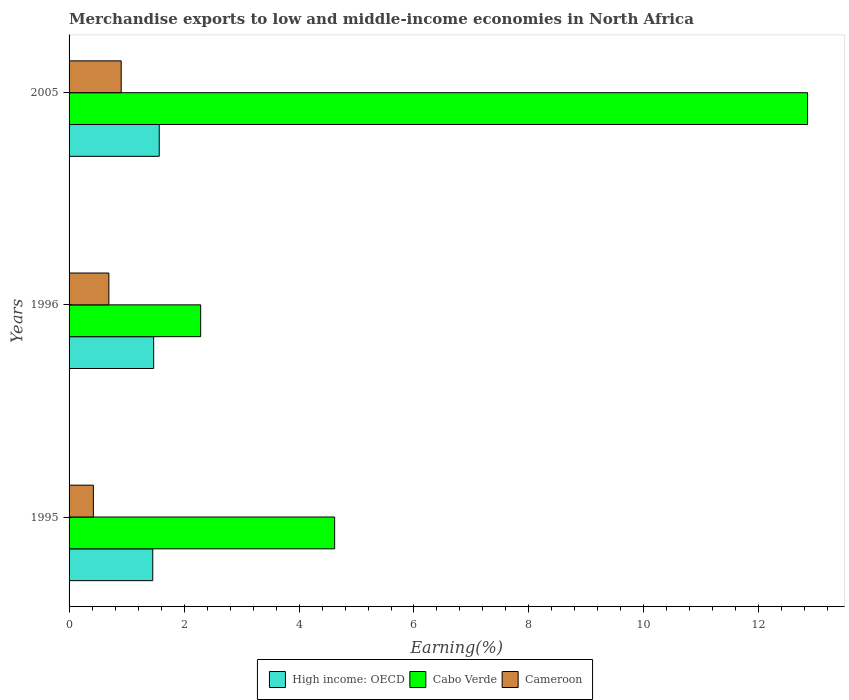How many groups of bars are there?
Provide a short and direct response. 3. Are the number of bars on each tick of the Y-axis equal?
Give a very brief answer. Yes. What is the percentage of amount earned from merchandise exports in Cabo Verde in 1995?
Provide a succinct answer. 4.62. Across all years, what is the maximum percentage of amount earned from merchandise exports in Cameroon?
Keep it short and to the point. 0.91. Across all years, what is the minimum percentage of amount earned from merchandise exports in High income: OECD?
Your answer should be very brief. 1.46. In which year was the percentage of amount earned from merchandise exports in Cameroon minimum?
Offer a very short reply. 1995. What is the total percentage of amount earned from merchandise exports in Cabo Verde in the graph?
Your answer should be very brief. 19.76. What is the difference between the percentage of amount earned from merchandise exports in Cameroon in 1995 and that in 2005?
Your answer should be very brief. -0.48. What is the difference between the percentage of amount earned from merchandise exports in Cabo Verde in 1996 and the percentage of amount earned from merchandise exports in Cameroon in 1995?
Provide a succinct answer. 1.87. What is the average percentage of amount earned from merchandise exports in Cabo Verde per year?
Provide a succinct answer. 6.59. In the year 1995, what is the difference between the percentage of amount earned from merchandise exports in Cameroon and percentage of amount earned from merchandise exports in High income: OECD?
Give a very brief answer. -1.03. In how many years, is the percentage of amount earned from merchandise exports in Cameroon greater than 8.4 %?
Keep it short and to the point. 0. What is the ratio of the percentage of amount earned from merchandise exports in Cameroon in 1995 to that in 1996?
Your answer should be very brief. 0.61. Is the percentage of amount earned from merchandise exports in Cabo Verde in 1996 less than that in 2005?
Offer a very short reply. Yes. What is the difference between the highest and the second highest percentage of amount earned from merchandise exports in High income: OECD?
Make the answer very short. 0.1. What is the difference between the highest and the lowest percentage of amount earned from merchandise exports in Cameroon?
Your answer should be very brief. 0.48. In how many years, is the percentage of amount earned from merchandise exports in Cameroon greater than the average percentage of amount earned from merchandise exports in Cameroon taken over all years?
Make the answer very short. 2. What does the 2nd bar from the top in 1995 represents?
Offer a terse response. Cabo Verde. What does the 3rd bar from the bottom in 1996 represents?
Make the answer very short. Cameroon. Is it the case that in every year, the sum of the percentage of amount earned from merchandise exports in High income: OECD and percentage of amount earned from merchandise exports in Cameroon is greater than the percentage of amount earned from merchandise exports in Cabo Verde?
Your answer should be very brief. No. How many bars are there?
Your answer should be compact. 9. Are the values on the major ticks of X-axis written in scientific E-notation?
Ensure brevity in your answer.  No. Does the graph contain any zero values?
Your answer should be compact. No. Does the graph contain grids?
Make the answer very short. No. Where does the legend appear in the graph?
Give a very brief answer. Bottom center. How many legend labels are there?
Make the answer very short. 3. How are the legend labels stacked?
Your answer should be compact. Horizontal. What is the title of the graph?
Your response must be concise. Merchandise exports to low and middle-income economies in North Africa. Does "New Caledonia" appear as one of the legend labels in the graph?
Your answer should be very brief. No. What is the label or title of the X-axis?
Your answer should be compact. Earning(%). What is the label or title of the Y-axis?
Your response must be concise. Years. What is the Earning(%) in High income: OECD in 1995?
Your response must be concise. 1.46. What is the Earning(%) in Cabo Verde in 1995?
Ensure brevity in your answer.  4.62. What is the Earning(%) in Cameroon in 1995?
Provide a succinct answer. 0.42. What is the Earning(%) of High income: OECD in 1996?
Your answer should be compact. 1.47. What is the Earning(%) in Cabo Verde in 1996?
Your answer should be compact. 2.29. What is the Earning(%) in Cameroon in 1996?
Offer a terse response. 0.69. What is the Earning(%) in High income: OECD in 2005?
Your answer should be very brief. 1.57. What is the Earning(%) of Cabo Verde in 2005?
Offer a very short reply. 12.85. What is the Earning(%) in Cameroon in 2005?
Your response must be concise. 0.91. Across all years, what is the maximum Earning(%) in High income: OECD?
Provide a short and direct response. 1.57. Across all years, what is the maximum Earning(%) of Cabo Verde?
Make the answer very short. 12.85. Across all years, what is the maximum Earning(%) in Cameroon?
Offer a very short reply. 0.91. Across all years, what is the minimum Earning(%) in High income: OECD?
Give a very brief answer. 1.46. Across all years, what is the minimum Earning(%) in Cabo Verde?
Your answer should be compact. 2.29. Across all years, what is the minimum Earning(%) in Cameroon?
Ensure brevity in your answer.  0.42. What is the total Earning(%) of High income: OECD in the graph?
Keep it short and to the point. 4.5. What is the total Earning(%) in Cabo Verde in the graph?
Your response must be concise. 19.76. What is the total Earning(%) in Cameroon in the graph?
Give a very brief answer. 2.02. What is the difference between the Earning(%) of High income: OECD in 1995 and that in 1996?
Keep it short and to the point. -0.02. What is the difference between the Earning(%) of Cabo Verde in 1995 and that in 1996?
Give a very brief answer. 2.33. What is the difference between the Earning(%) in Cameroon in 1995 and that in 1996?
Your response must be concise. -0.27. What is the difference between the Earning(%) in High income: OECD in 1995 and that in 2005?
Your response must be concise. -0.11. What is the difference between the Earning(%) in Cabo Verde in 1995 and that in 2005?
Your response must be concise. -8.23. What is the difference between the Earning(%) of Cameroon in 1995 and that in 2005?
Your answer should be compact. -0.48. What is the difference between the Earning(%) of High income: OECD in 1996 and that in 2005?
Provide a succinct answer. -0.1. What is the difference between the Earning(%) in Cabo Verde in 1996 and that in 2005?
Ensure brevity in your answer.  -10.56. What is the difference between the Earning(%) of Cameroon in 1996 and that in 2005?
Offer a terse response. -0.21. What is the difference between the Earning(%) of High income: OECD in 1995 and the Earning(%) of Cabo Verde in 1996?
Offer a terse response. -0.83. What is the difference between the Earning(%) in High income: OECD in 1995 and the Earning(%) in Cameroon in 1996?
Your answer should be compact. 0.76. What is the difference between the Earning(%) of Cabo Verde in 1995 and the Earning(%) of Cameroon in 1996?
Your answer should be very brief. 3.93. What is the difference between the Earning(%) of High income: OECD in 1995 and the Earning(%) of Cabo Verde in 2005?
Your answer should be compact. -11.39. What is the difference between the Earning(%) of High income: OECD in 1995 and the Earning(%) of Cameroon in 2005?
Your answer should be compact. 0.55. What is the difference between the Earning(%) of Cabo Verde in 1995 and the Earning(%) of Cameroon in 2005?
Keep it short and to the point. 3.71. What is the difference between the Earning(%) of High income: OECD in 1996 and the Earning(%) of Cabo Verde in 2005?
Offer a terse response. -11.38. What is the difference between the Earning(%) in High income: OECD in 1996 and the Earning(%) in Cameroon in 2005?
Ensure brevity in your answer.  0.56. What is the difference between the Earning(%) of Cabo Verde in 1996 and the Earning(%) of Cameroon in 2005?
Your answer should be compact. 1.38. What is the average Earning(%) in High income: OECD per year?
Offer a terse response. 1.5. What is the average Earning(%) of Cabo Verde per year?
Ensure brevity in your answer.  6.59. What is the average Earning(%) of Cameroon per year?
Offer a terse response. 0.67. In the year 1995, what is the difference between the Earning(%) in High income: OECD and Earning(%) in Cabo Verde?
Give a very brief answer. -3.16. In the year 1995, what is the difference between the Earning(%) of High income: OECD and Earning(%) of Cameroon?
Your response must be concise. 1.03. In the year 1995, what is the difference between the Earning(%) of Cabo Verde and Earning(%) of Cameroon?
Your answer should be very brief. 4.2. In the year 1996, what is the difference between the Earning(%) in High income: OECD and Earning(%) in Cabo Verde?
Give a very brief answer. -0.82. In the year 1996, what is the difference between the Earning(%) in High income: OECD and Earning(%) in Cameroon?
Offer a terse response. 0.78. In the year 1996, what is the difference between the Earning(%) in Cabo Verde and Earning(%) in Cameroon?
Ensure brevity in your answer.  1.6. In the year 2005, what is the difference between the Earning(%) in High income: OECD and Earning(%) in Cabo Verde?
Your answer should be very brief. -11.28. In the year 2005, what is the difference between the Earning(%) of High income: OECD and Earning(%) of Cameroon?
Provide a short and direct response. 0.66. In the year 2005, what is the difference between the Earning(%) of Cabo Verde and Earning(%) of Cameroon?
Give a very brief answer. 11.94. What is the ratio of the Earning(%) of Cabo Verde in 1995 to that in 1996?
Make the answer very short. 2.02. What is the ratio of the Earning(%) of Cameroon in 1995 to that in 1996?
Give a very brief answer. 0.61. What is the ratio of the Earning(%) in High income: OECD in 1995 to that in 2005?
Give a very brief answer. 0.93. What is the ratio of the Earning(%) in Cabo Verde in 1995 to that in 2005?
Your answer should be very brief. 0.36. What is the ratio of the Earning(%) of Cameroon in 1995 to that in 2005?
Offer a very short reply. 0.47. What is the ratio of the Earning(%) in High income: OECD in 1996 to that in 2005?
Give a very brief answer. 0.94. What is the ratio of the Earning(%) of Cabo Verde in 1996 to that in 2005?
Offer a terse response. 0.18. What is the ratio of the Earning(%) of Cameroon in 1996 to that in 2005?
Your answer should be very brief. 0.76. What is the difference between the highest and the second highest Earning(%) of High income: OECD?
Ensure brevity in your answer.  0.1. What is the difference between the highest and the second highest Earning(%) in Cabo Verde?
Your response must be concise. 8.23. What is the difference between the highest and the second highest Earning(%) of Cameroon?
Ensure brevity in your answer.  0.21. What is the difference between the highest and the lowest Earning(%) of High income: OECD?
Provide a succinct answer. 0.11. What is the difference between the highest and the lowest Earning(%) of Cabo Verde?
Give a very brief answer. 10.56. What is the difference between the highest and the lowest Earning(%) in Cameroon?
Offer a terse response. 0.48. 